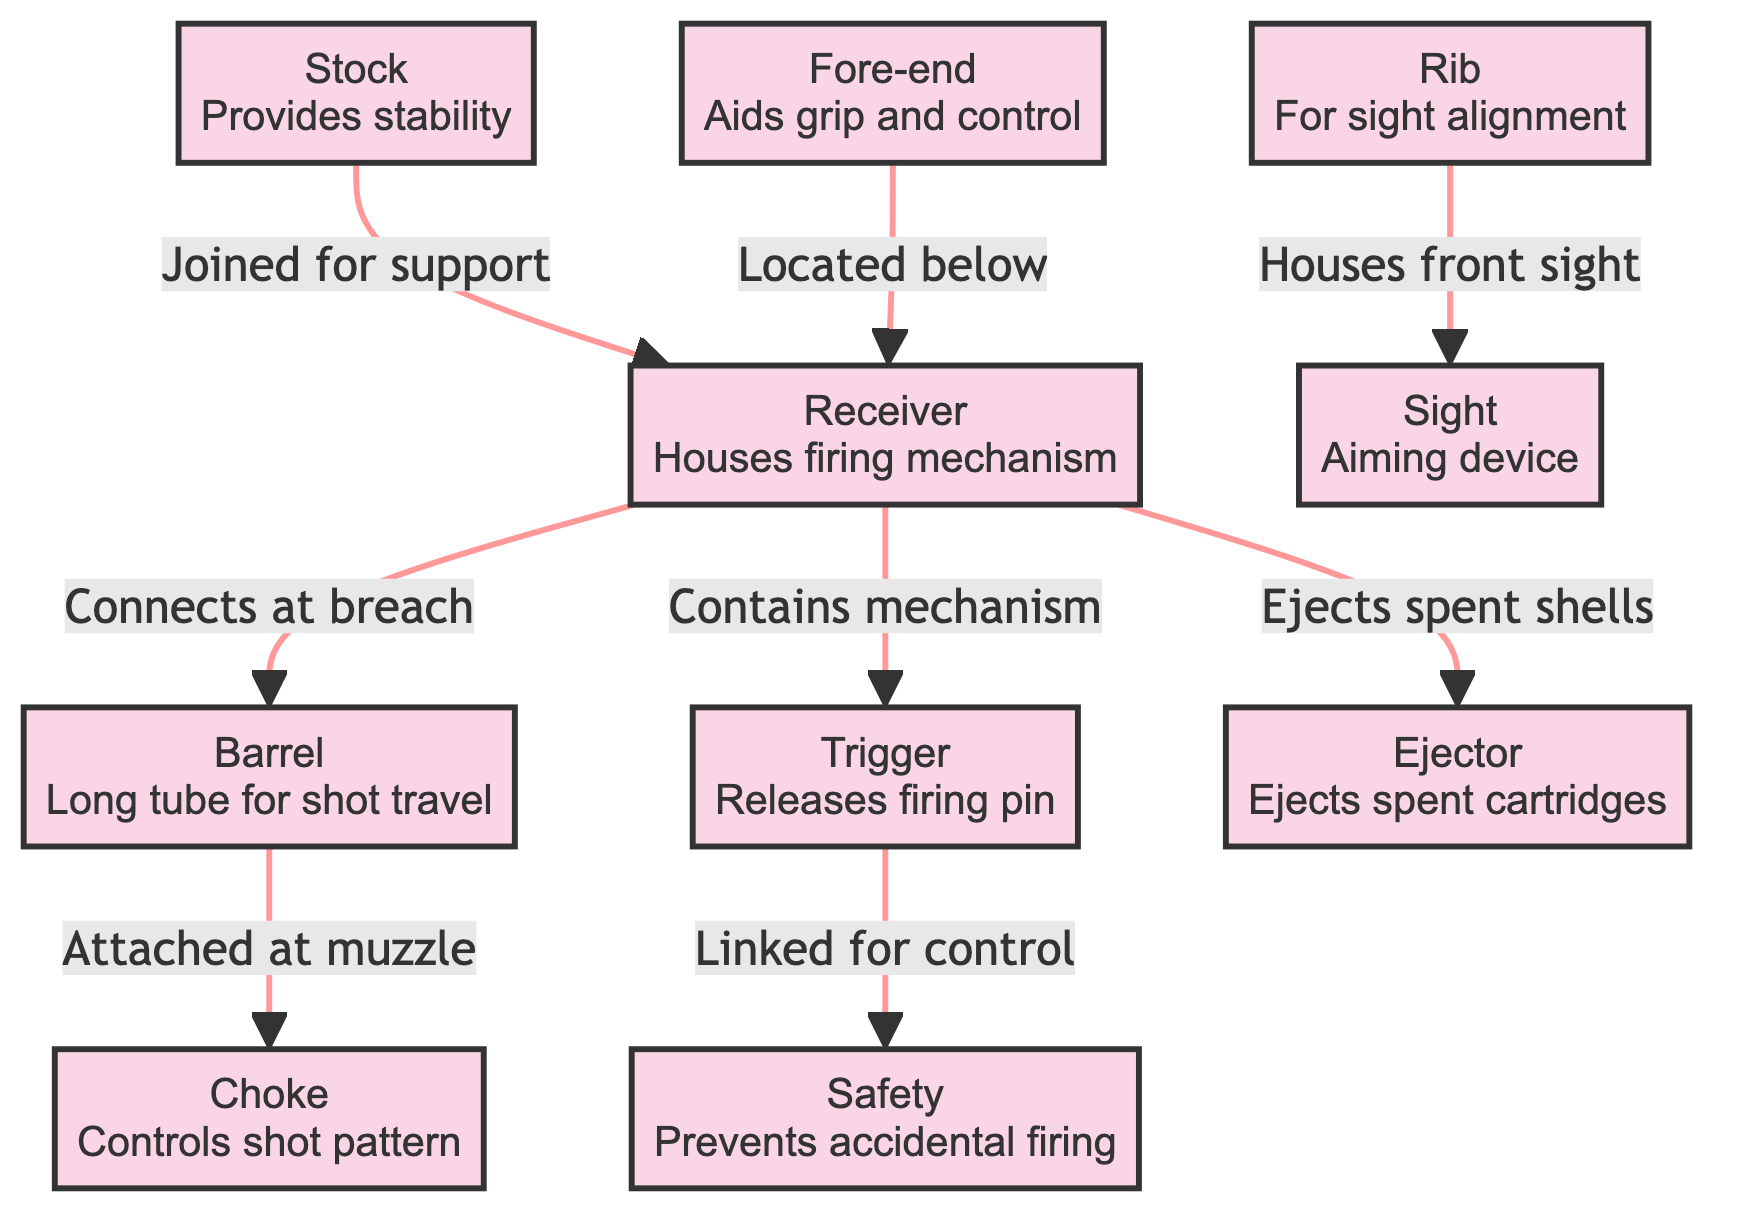What is the function of the barrel? The barrel is described as a "Long tube for shot travel," meaning its primary purpose is to allow the shot to travel down its length towards the target.
Answer: Long tube for shot travel Which part connects to the barrel at the breach? The diagram indicates that the "Receiver" is the component that connects to the barrel at the breach, as indicated by the relationship shown in the diagram.
Answer: Receiver How many parts are linked to the receiver? By analyzing the diagram, the receiver has connections to five different parts: barrel, trigger, stock, ejector, and fore-end. Counting these connections gives the total.
Answer: 5 What part aids in sight alignment? The diagram specifies that the "Rib" is the part that "For sight alignment," making it the specific component that aids in aligning sights for aiming.
Answer: Rib What does the trigger release? The function of the trigger is explicitly mentioned in the diagram as "Releases firing pin," indicating that its key role is to activate the firing mechanism.
Answer: Firing pin Which part prevents accidental firing? According to the diagram, the part that prevents accidental firing is labeled "Safety," indicating its essential role in firearm safety.
Answer: Safety What connects the trigger and safety? The relationship shown in the diagram states that the trigger is "Linked for control" to the safety, illustrating how these two components interact for operation safety.
Answer: Linked for control Which component is located below the receiver? The diagram clearly states that the "Fore-end" is located below the receiver, thus making it easy to identify its relative position.
Answer: Fore-end How does the ejector function in relation to the receiver? The diagram indicates that the receiver "Ejects spent shells" using the ejector, showing a direct functional relationship between them. Therefore, the ejector is responsible for ejecting the used cartridges.
Answer: Ejects spent shells 